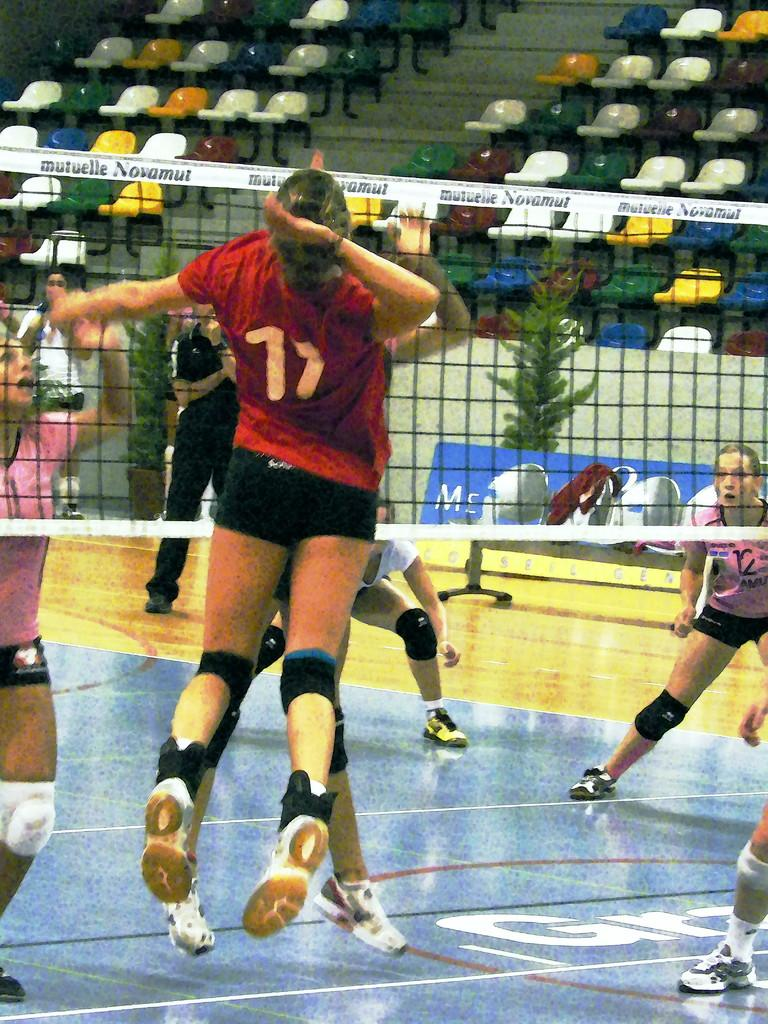What is happening on the ground in the image? There are people on the ground in the image. What object is present that might be used for a game or sport? There is a net visible in the image. What type of natural elements can be seen in the background of the image? There are plants in the background of the image. What type of furniture is visible in the background of the image? There are chairs in the background of the image. What type of vest is being worn by the lawyer in the image? There is no lawyer or vest present in the image. How does the acoustics of the area affect the sound quality in the image? The provided facts do not mention anything about the acoustics of the area, so it cannot be determined from the image. 